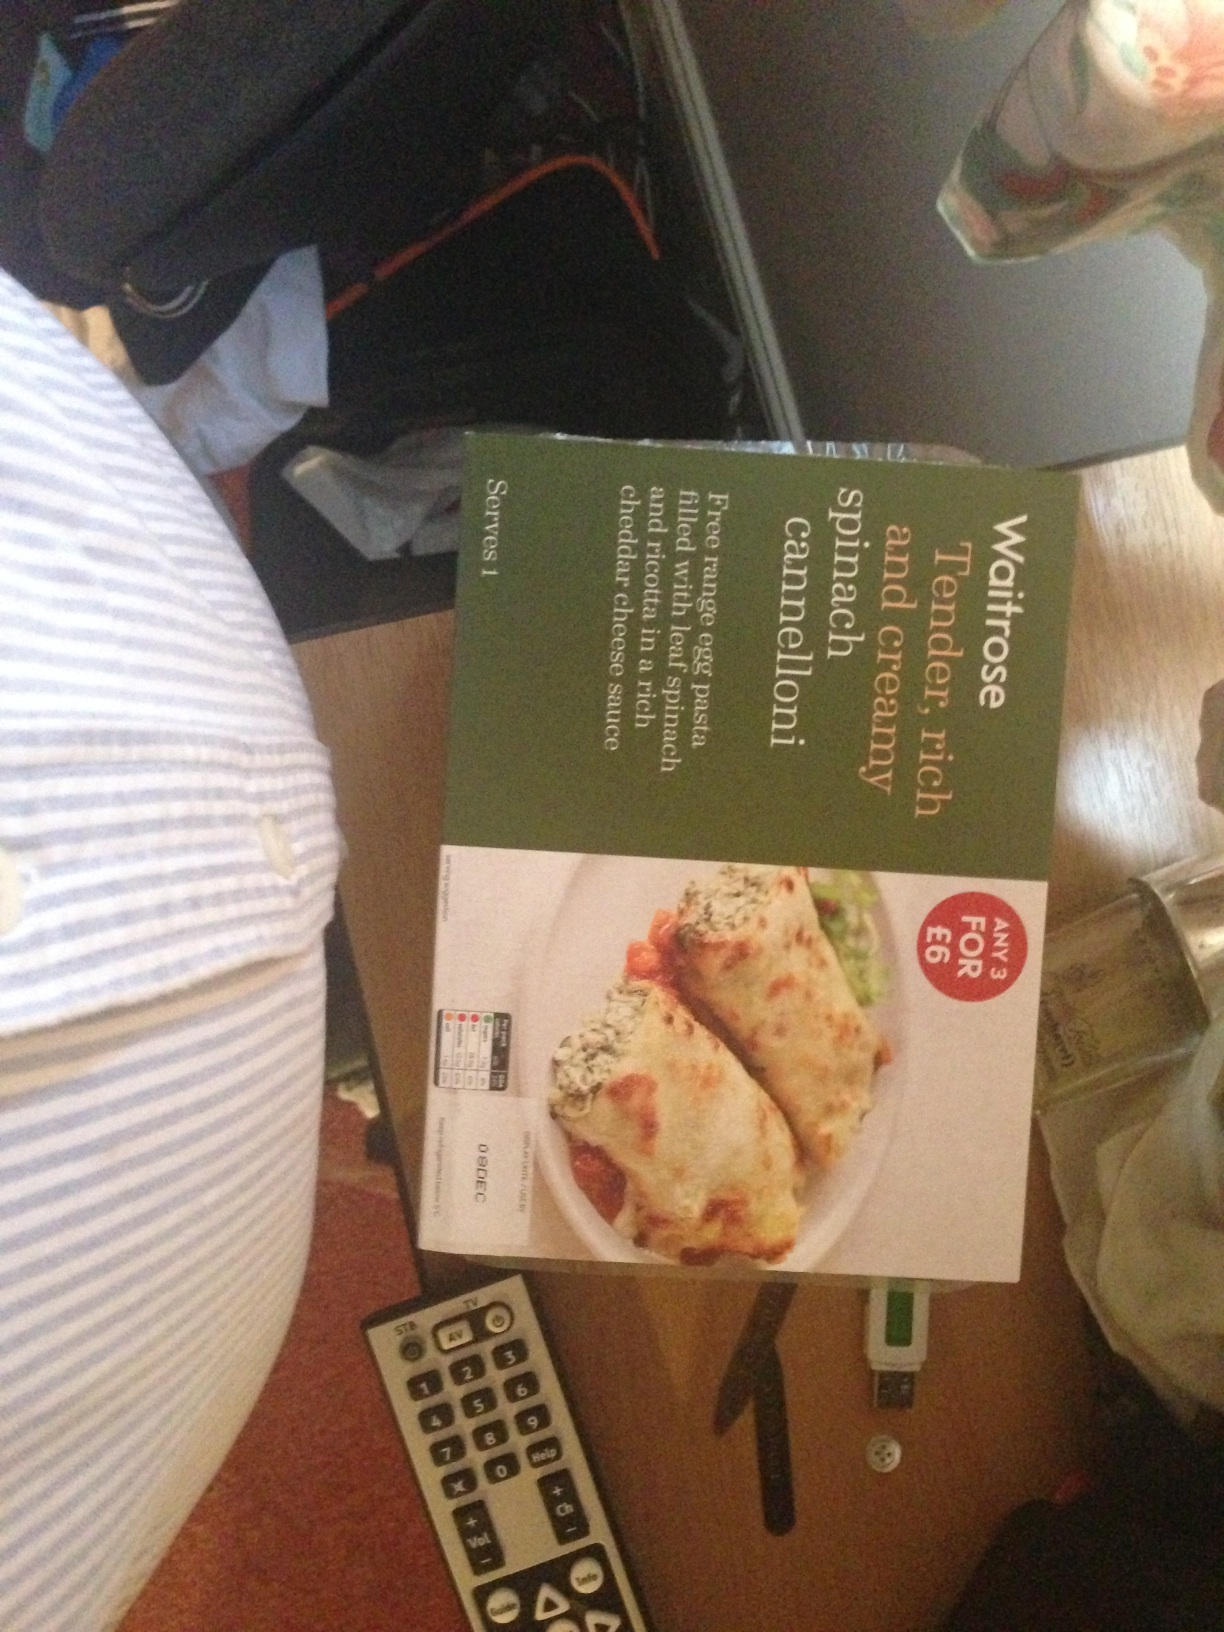I just would like to know which ready meal this is. The ready meal displayed in the image is a Waitrose brand 'Tender, rich spinach cannelloni,' a pasta dish filled with spinach and covered in creamy sauce and melted cheese. This dish serves one and appears to be from a deal offering, making it not only a convenient choice for a quick and tasty meal but also potentially a cost-effective option. 